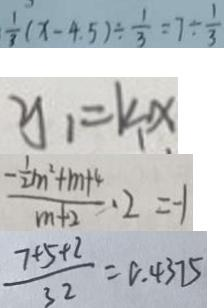Convert formula to latex. <formula><loc_0><loc_0><loc_500><loc_500>\frac { 1 } { 3 } ( x - 4 . 5 ) \div \frac { 1 } { 3 } = 7 \div \frac { 1 } { 3 } 
 y _ { 1 } = k _ { 1 } x 
 \frac { - \frac { 1 } { 2 } m ^ { 2 } + m + 4 } { m + 2 } \cdot 2 = - 1 
 \frac { 7 + 5 + 2 } { 3 2 } = 0 \cdot 4 3 7 5</formula> 